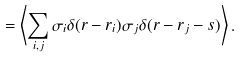<formula> <loc_0><loc_0><loc_500><loc_500>= \left < \sum _ { i , j } \sigma _ { i } \delta ( { r - r } _ { i } ) \sigma _ { j } \delta ( { r - r } _ { j } - { s } ) \right > .</formula> 